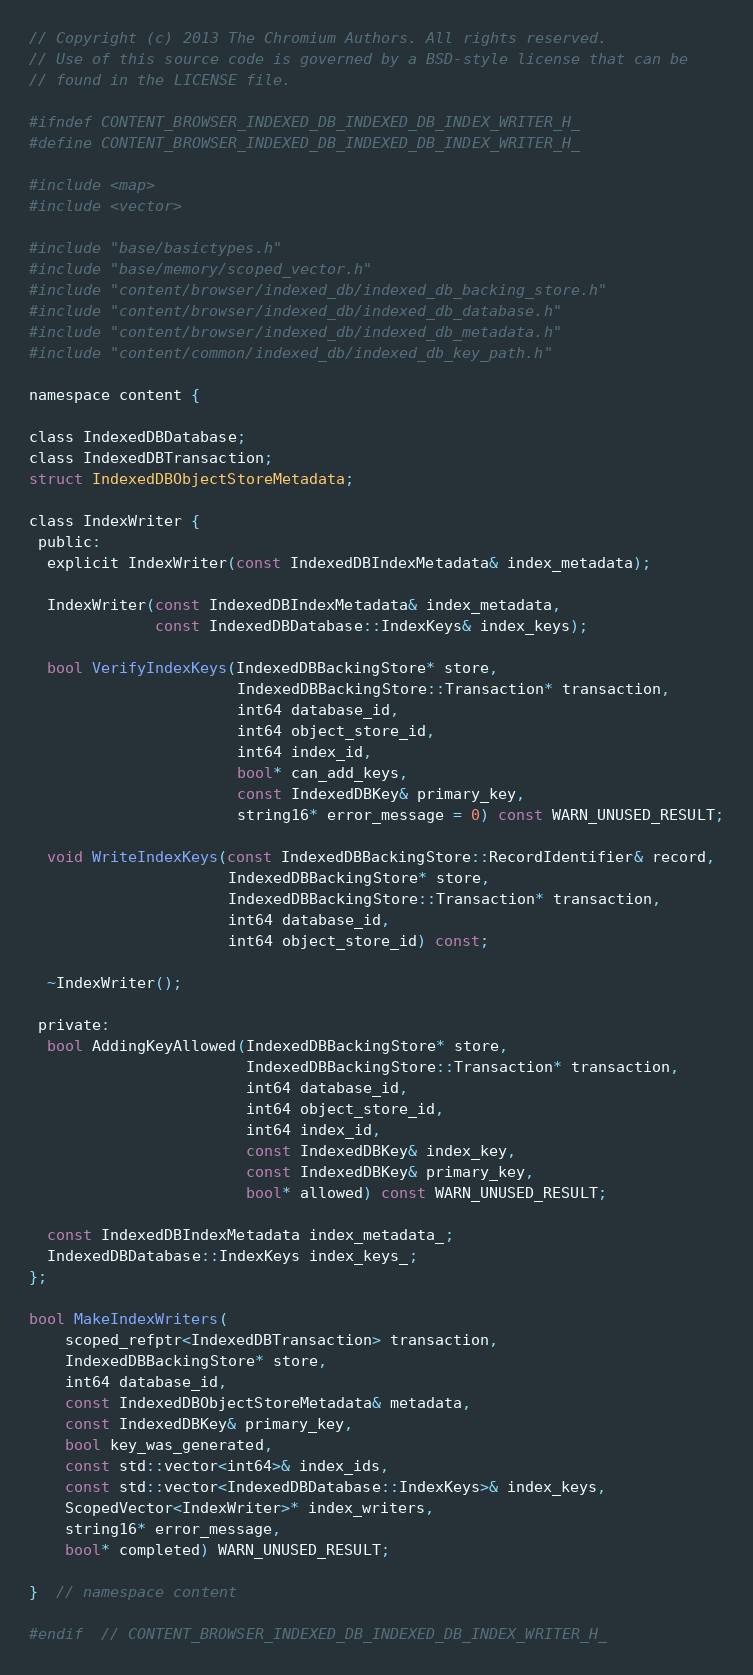<code> <loc_0><loc_0><loc_500><loc_500><_C_>// Copyright (c) 2013 The Chromium Authors. All rights reserved.
// Use of this source code is governed by a BSD-style license that can be
// found in the LICENSE file.

#ifndef CONTENT_BROWSER_INDEXED_DB_INDEXED_DB_INDEX_WRITER_H_
#define CONTENT_BROWSER_INDEXED_DB_INDEXED_DB_INDEX_WRITER_H_

#include <map>
#include <vector>

#include "base/basictypes.h"
#include "base/memory/scoped_vector.h"
#include "content/browser/indexed_db/indexed_db_backing_store.h"
#include "content/browser/indexed_db/indexed_db_database.h"
#include "content/browser/indexed_db/indexed_db_metadata.h"
#include "content/common/indexed_db/indexed_db_key_path.h"

namespace content {

class IndexedDBDatabase;
class IndexedDBTransaction;
struct IndexedDBObjectStoreMetadata;

class IndexWriter {
 public:
  explicit IndexWriter(const IndexedDBIndexMetadata& index_metadata);

  IndexWriter(const IndexedDBIndexMetadata& index_metadata,
              const IndexedDBDatabase::IndexKeys& index_keys);

  bool VerifyIndexKeys(IndexedDBBackingStore* store,
                       IndexedDBBackingStore::Transaction* transaction,
                       int64 database_id,
                       int64 object_store_id,
                       int64 index_id,
                       bool* can_add_keys,
                       const IndexedDBKey& primary_key,
                       string16* error_message = 0) const WARN_UNUSED_RESULT;

  void WriteIndexKeys(const IndexedDBBackingStore::RecordIdentifier& record,
                      IndexedDBBackingStore* store,
                      IndexedDBBackingStore::Transaction* transaction,
                      int64 database_id,
                      int64 object_store_id) const;

  ~IndexWriter();

 private:
  bool AddingKeyAllowed(IndexedDBBackingStore* store,
                        IndexedDBBackingStore::Transaction* transaction,
                        int64 database_id,
                        int64 object_store_id,
                        int64 index_id,
                        const IndexedDBKey& index_key,
                        const IndexedDBKey& primary_key,
                        bool* allowed) const WARN_UNUSED_RESULT;

  const IndexedDBIndexMetadata index_metadata_;
  IndexedDBDatabase::IndexKeys index_keys_;
};

bool MakeIndexWriters(
    scoped_refptr<IndexedDBTransaction> transaction,
    IndexedDBBackingStore* store,
    int64 database_id,
    const IndexedDBObjectStoreMetadata& metadata,
    const IndexedDBKey& primary_key,
    bool key_was_generated,
    const std::vector<int64>& index_ids,
    const std::vector<IndexedDBDatabase::IndexKeys>& index_keys,
    ScopedVector<IndexWriter>* index_writers,
    string16* error_message,
    bool* completed) WARN_UNUSED_RESULT;

}  // namespace content

#endif  // CONTENT_BROWSER_INDEXED_DB_INDEXED_DB_INDEX_WRITER_H_
</code> 